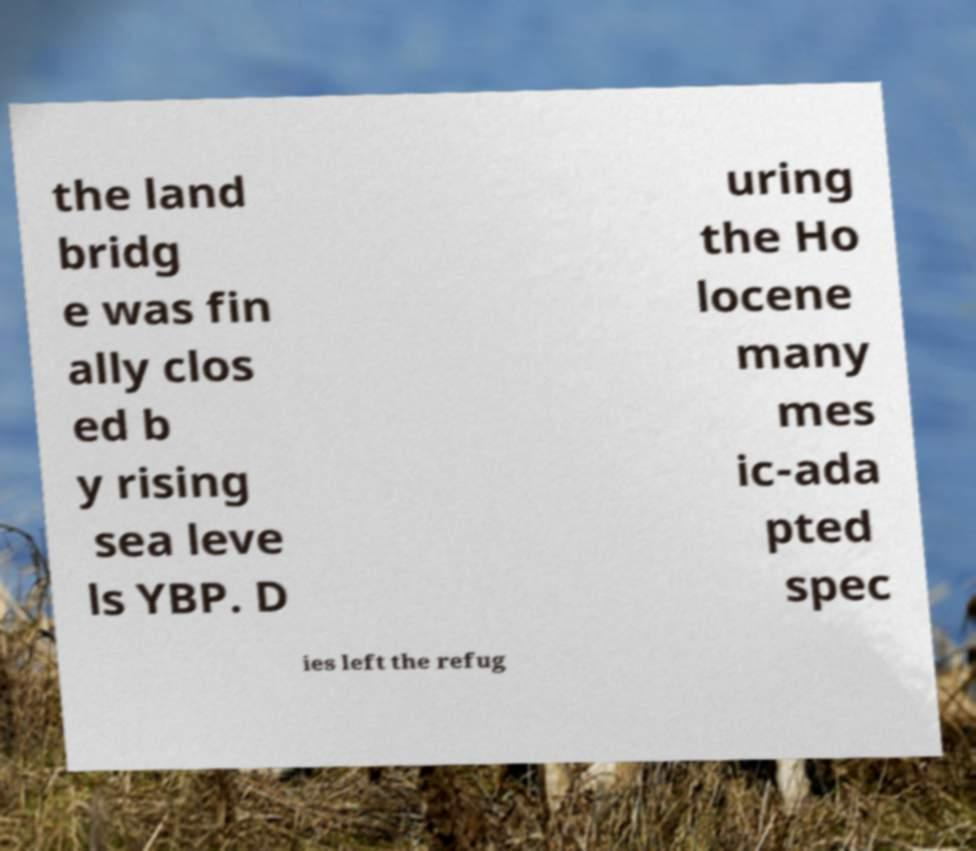What messages or text are displayed in this image? I need them in a readable, typed format. the land bridg e was fin ally clos ed b y rising sea leve ls YBP. D uring the Ho locene many mes ic-ada pted spec ies left the refug 